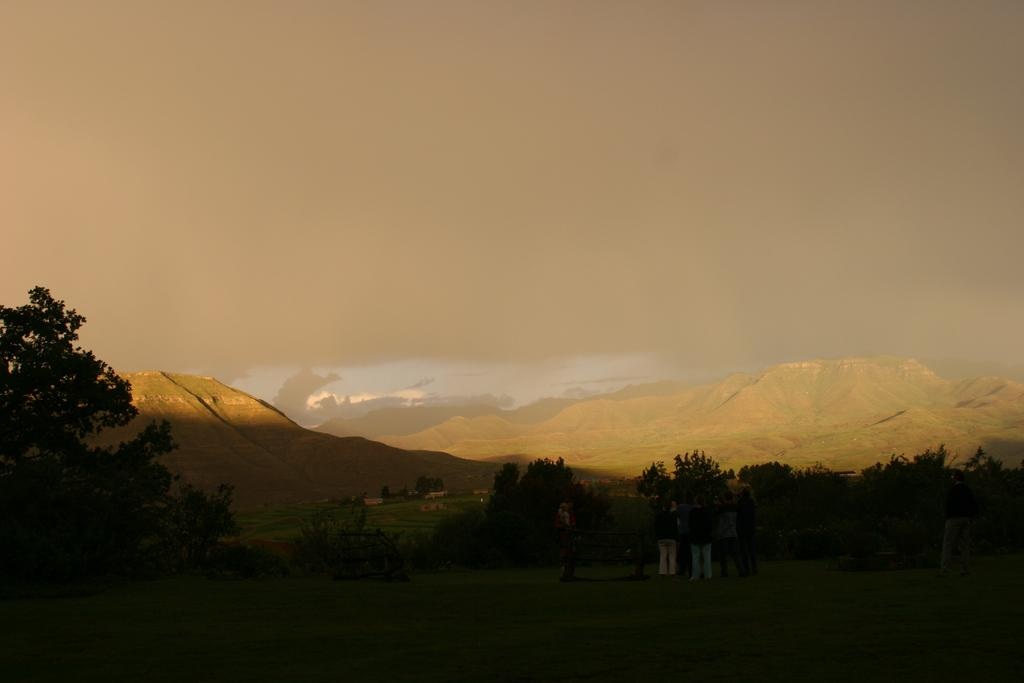What can be seen in the image involving human presence? There are people standing in the image. What type of vegetation is present in the image? There are trees in the image. What is the ground surface like in the image? There is grass at the bottom of the image. What type of landscape feature can be seen in the image? There are hills visible in the image. What is visible at the top of the image? The sky is visible at the top of the image. What type of division is taking place in the image? There is no division present in the image; it features people, trees, grass, hills, and the sky. What impulse can be observed in the people in the image? There is no specific impulse observable in the people in the image; they are simply standing. 